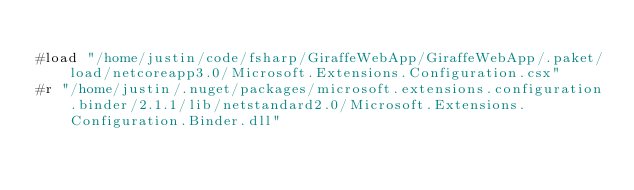<code> <loc_0><loc_0><loc_500><loc_500><_C#_>
#load "/home/justin/code/fsharp/GiraffeWebApp/GiraffeWebApp/.paket/load/netcoreapp3.0/Microsoft.Extensions.Configuration.csx" 
#r "/home/justin/.nuget/packages/microsoft.extensions.configuration.binder/2.1.1/lib/netstandard2.0/Microsoft.Extensions.Configuration.Binder.dll" </code> 